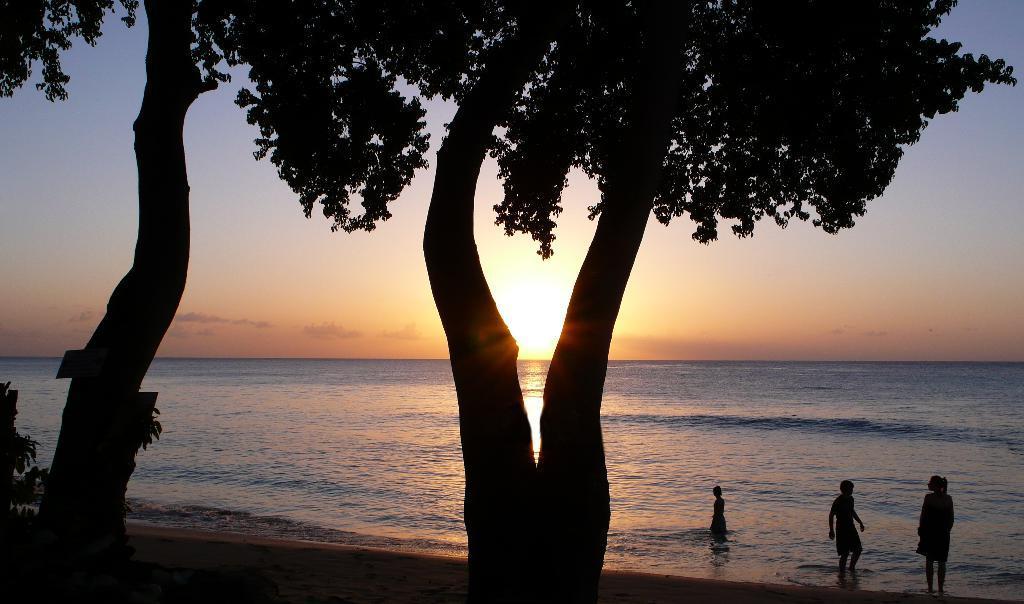In one or two sentences, can you explain what this image depicts? In this image, on the right side, we can see three persons in the water, we can see the trees and the sunset. 